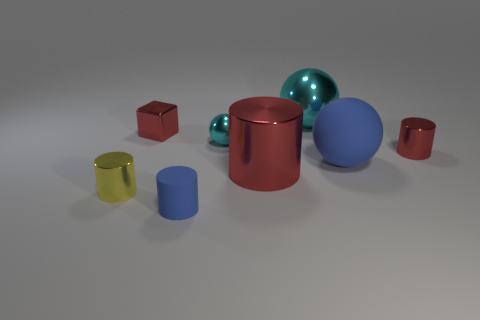How many small metal cylinders are to the left of the tiny metallic cylinder behind the object that is left of the small red metal cube?
Keep it short and to the point. 1. How many rubber things are big cyan things or tiny cyan spheres?
Ensure brevity in your answer.  0. There is a tiny thing that is both in front of the big red metal cylinder and on the left side of the small rubber thing; what color is it?
Keep it short and to the point. Yellow. There is a thing behind the red metallic cube; does it have the same size as the blue cylinder?
Offer a very short reply. No. How many objects are cyan metal balls right of the tiny cyan object or small cylinders?
Your response must be concise. 4. Is there a red shiny cylinder of the same size as the yellow metallic thing?
Provide a succinct answer. Yes. There is a blue object that is the same size as the red cube; what material is it?
Make the answer very short. Rubber. The metallic thing that is to the left of the tiny sphere and on the right side of the yellow cylinder has what shape?
Ensure brevity in your answer.  Cube. What is the color of the small object on the right side of the large metallic sphere?
Your answer should be very brief. Red. There is a thing that is both on the right side of the small blue matte cylinder and behind the small cyan shiny ball; how big is it?
Your response must be concise. Large. 